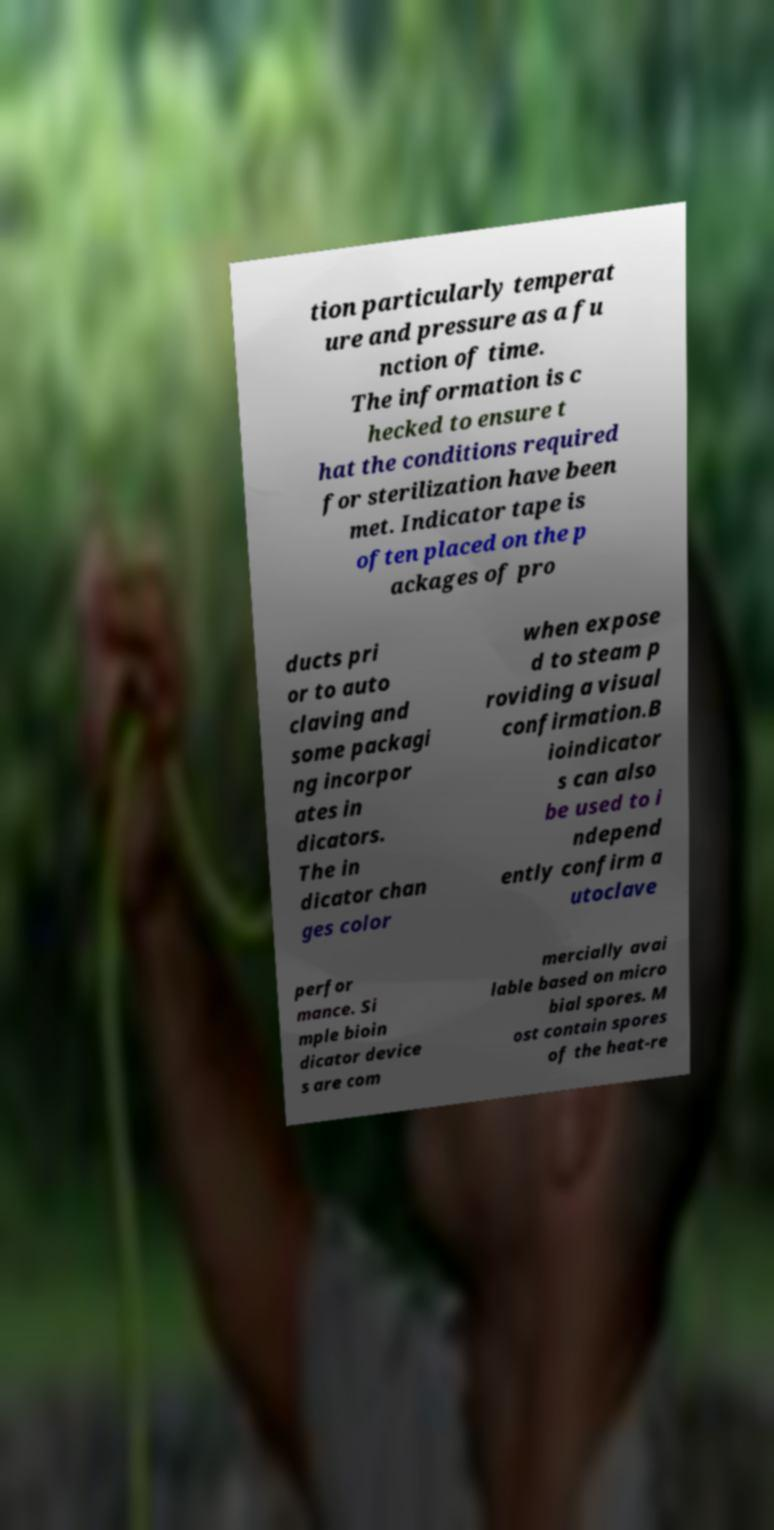I need the written content from this picture converted into text. Can you do that? tion particularly temperat ure and pressure as a fu nction of time. The information is c hecked to ensure t hat the conditions required for sterilization have been met. Indicator tape is often placed on the p ackages of pro ducts pri or to auto claving and some packagi ng incorpor ates in dicators. The in dicator chan ges color when expose d to steam p roviding a visual confirmation.B ioindicator s can also be used to i ndepend ently confirm a utoclave perfor mance. Si mple bioin dicator device s are com mercially avai lable based on micro bial spores. M ost contain spores of the heat-re 